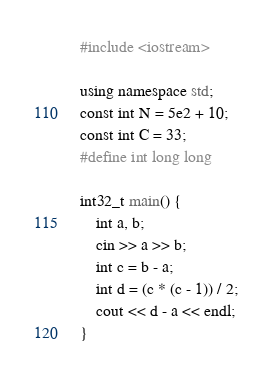<code> <loc_0><loc_0><loc_500><loc_500><_C++_>#include <iostream>

using namespace std;
const int N = 5e2 + 10;
const int C = 33;
#define int long long

int32_t main() {
	int a, b;
	cin >> a >> b;
	int c = b - a;
	int d = (c * (c - 1)) / 2;
	cout << d - a << endl;
}
</code> 